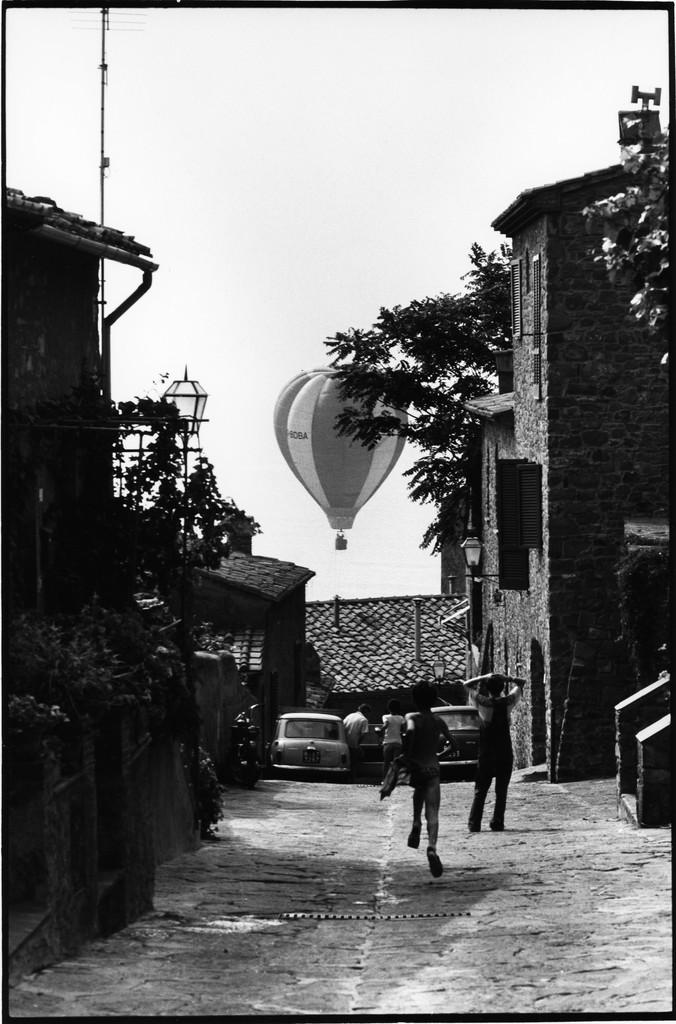What types of subjects can be seen in the image? There are people, vehicles, buildings, a pole, plants, and paragliding visible in the image. Can you describe the setting of the image? The image features a combination of urban and natural elements, including buildings, plants, and paragliding. What is the background of the image? The sky is visible in the background of the image. What type of grain is being stored in the drawer in the image? There is no drawer or grain present in the image. How many potatoes can be seen in the image? There are no potatoes visible in the image. 